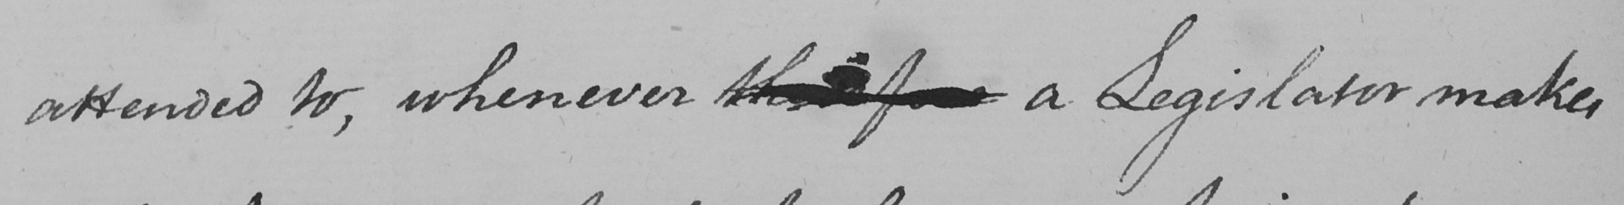What does this handwritten line say? attended to , whenever therefore a Legislator makes 